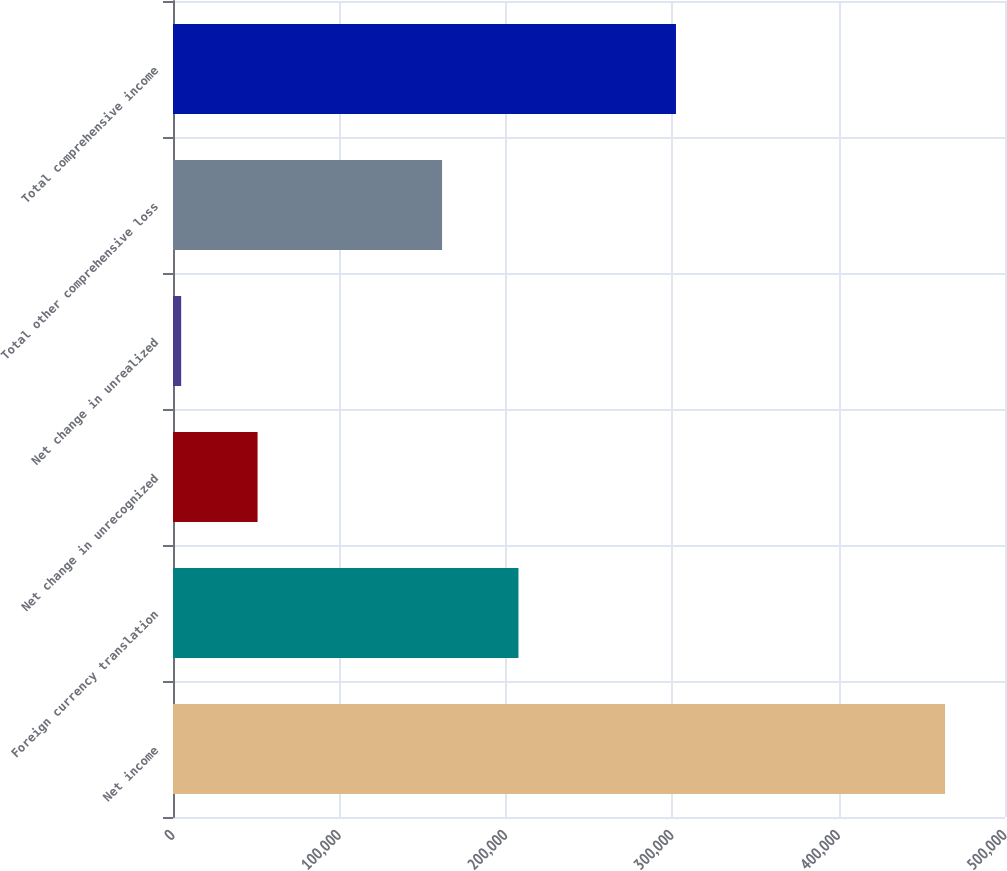Convert chart to OTSL. <chart><loc_0><loc_0><loc_500><loc_500><bar_chart><fcel>Net income<fcel>Foreign currency translation<fcel>Net change in unrecognized<fcel>Net change in unrealized<fcel>Total other comprehensive loss<fcel>Total comprehensive income<nl><fcel>463975<fcel>207611<fcel>50817.4<fcel>4911<fcel>161705<fcel>302270<nl></chart> 